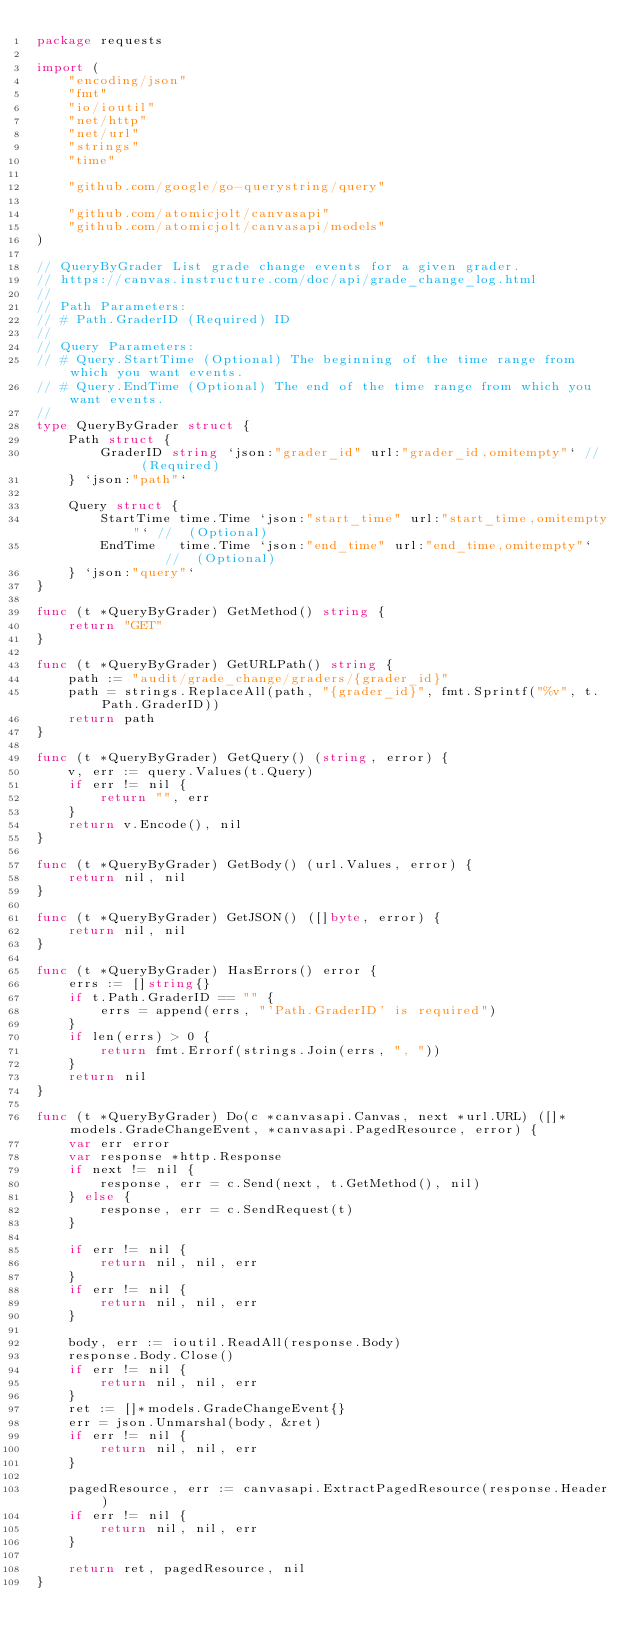<code> <loc_0><loc_0><loc_500><loc_500><_Go_>package requests

import (
	"encoding/json"
	"fmt"
	"io/ioutil"
	"net/http"
	"net/url"
	"strings"
	"time"

	"github.com/google/go-querystring/query"

	"github.com/atomicjolt/canvasapi"
	"github.com/atomicjolt/canvasapi/models"
)

// QueryByGrader List grade change events for a given grader.
// https://canvas.instructure.com/doc/api/grade_change_log.html
//
// Path Parameters:
// # Path.GraderID (Required) ID
//
// Query Parameters:
// # Query.StartTime (Optional) The beginning of the time range from which you want events.
// # Query.EndTime (Optional) The end of the time range from which you want events.
//
type QueryByGrader struct {
	Path struct {
		GraderID string `json:"grader_id" url:"grader_id,omitempty"` //  (Required)
	} `json:"path"`

	Query struct {
		StartTime time.Time `json:"start_time" url:"start_time,omitempty"` //  (Optional)
		EndTime   time.Time `json:"end_time" url:"end_time,omitempty"`     //  (Optional)
	} `json:"query"`
}

func (t *QueryByGrader) GetMethod() string {
	return "GET"
}

func (t *QueryByGrader) GetURLPath() string {
	path := "audit/grade_change/graders/{grader_id}"
	path = strings.ReplaceAll(path, "{grader_id}", fmt.Sprintf("%v", t.Path.GraderID))
	return path
}

func (t *QueryByGrader) GetQuery() (string, error) {
	v, err := query.Values(t.Query)
	if err != nil {
		return "", err
	}
	return v.Encode(), nil
}

func (t *QueryByGrader) GetBody() (url.Values, error) {
	return nil, nil
}

func (t *QueryByGrader) GetJSON() ([]byte, error) {
	return nil, nil
}

func (t *QueryByGrader) HasErrors() error {
	errs := []string{}
	if t.Path.GraderID == "" {
		errs = append(errs, "'Path.GraderID' is required")
	}
	if len(errs) > 0 {
		return fmt.Errorf(strings.Join(errs, ", "))
	}
	return nil
}

func (t *QueryByGrader) Do(c *canvasapi.Canvas, next *url.URL) ([]*models.GradeChangeEvent, *canvasapi.PagedResource, error) {
	var err error
	var response *http.Response
	if next != nil {
		response, err = c.Send(next, t.GetMethod(), nil)
	} else {
		response, err = c.SendRequest(t)
	}

	if err != nil {
		return nil, nil, err
	}
	if err != nil {
		return nil, nil, err
	}

	body, err := ioutil.ReadAll(response.Body)
	response.Body.Close()
	if err != nil {
		return nil, nil, err
	}
	ret := []*models.GradeChangeEvent{}
	err = json.Unmarshal(body, &ret)
	if err != nil {
		return nil, nil, err
	}

	pagedResource, err := canvasapi.ExtractPagedResource(response.Header)
	if err != nil {
		return nil, nil, err
	}

	return ret, pagedResource, nil
}
</code> 